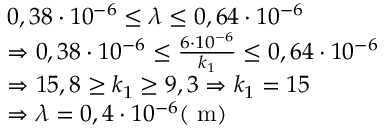Convert formula to latex. <formula><loc_0><loc_0><loc_500><loc_500>\begin{array} { r l } & { 0 , 3 8 \cdot 1 0 ^ { - 6 } \leq \lambda \leq 0 , 6 4 \cdot 1 0 ^ { - 6 } } \\ & { \Rightarrow 0 , 3 8 \cdot 1 0 ^ { - 6 } \leq \frac { 6 \cdot 1 0 ^ { - 6 } } { k _ { 1 } } \leq 0 , 6 4 \cdot 1 0 ^ { - 6 } } \\ & { \Rightarrow 1 5 , 8 \geq k _ { 1 } \geq 9 , 3 \Rightarrow k _ { 1 } = 1 5 } \\ & { \Rightarrow \lambda = 0 , 4 \cdot 1 0 ^ { - 6 } ( m ) } \end{array}</formula> 